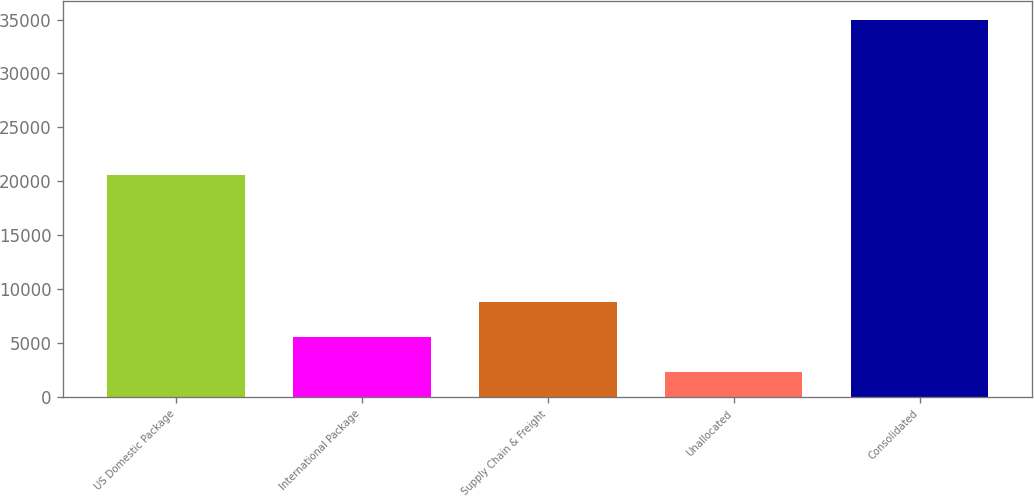Convert chart. <chart><loc_0><loc_0><loc_500><loc_500><bar_chart><fcel>US Domestic Package<fcel>International Package<fcel>Supply Chain & Freight<fcel>Unallocated<fcel>Consolidated<nl><fcel>20572<fcel>5589.9<fcel>8851.8<fcel>2328<fcel>34947<nl></chart> 